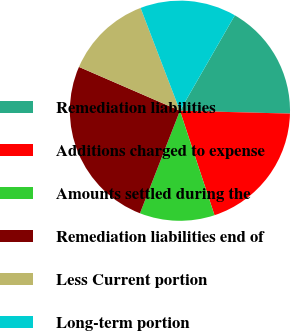Convert chart to OTSL. <chart><loc_0><loc_0><loc_500><loc_500><pie_chart><fcel>Remediation liabilities<fcel>Additions charged to expense<fcel>Amounts settled during the<fcel>Remediation liabilities end of<fcel>Less Current portion<fcel>Long-term portion<nl><fcel>17.11%<fcel>19.5%<fcel>11.0%<fcel>25.6%<fcel>12.67%<fcel>14.13%<nl></chart> 